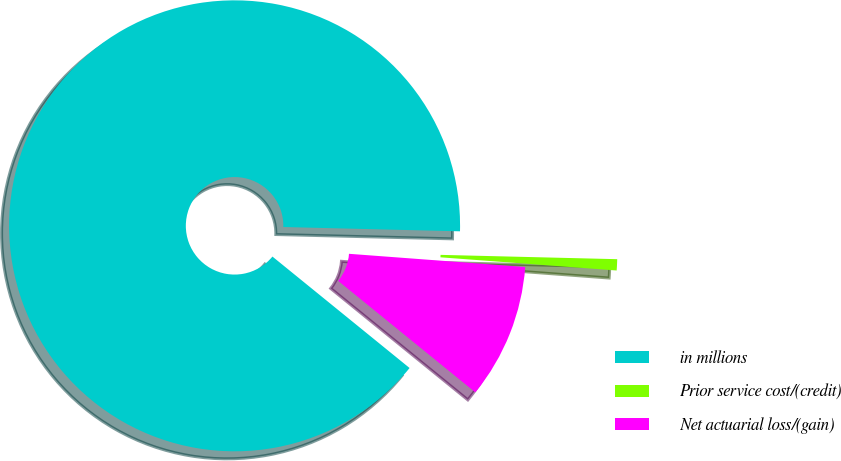<chart> <loc_0><loc_0><loc_500><loc_500><pie_chart><fcel>in millions<fcel>Prior service cost/(credit)<fcel>Net actuarial loss/(gain)<nl><fcel>89.52%<fcel>0.8%<fcel>9.67%<nl></chart> 